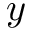Convert formula to latex. <formula><loc_0><loc_0><loc_500><loc_500>y</formula> 